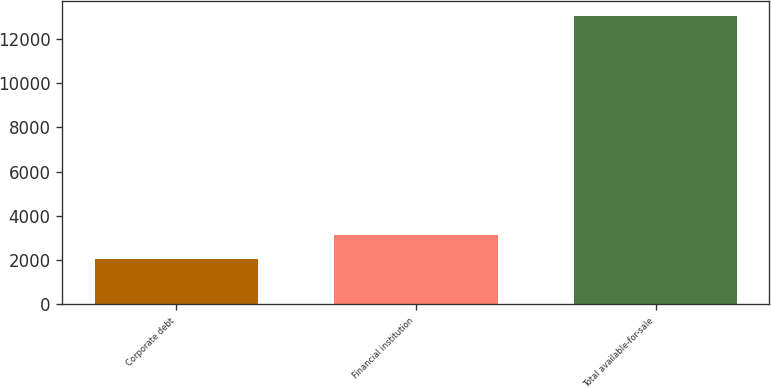<chart> <loc_0><loc_0><loc_500><loc_500><bar_chart><fcel>Corporate debt<fcel>Financial institution<fcel>Total available-for-sale<nl><fcel>2048<fcel>3147<fcel>13038<nl></chart> 